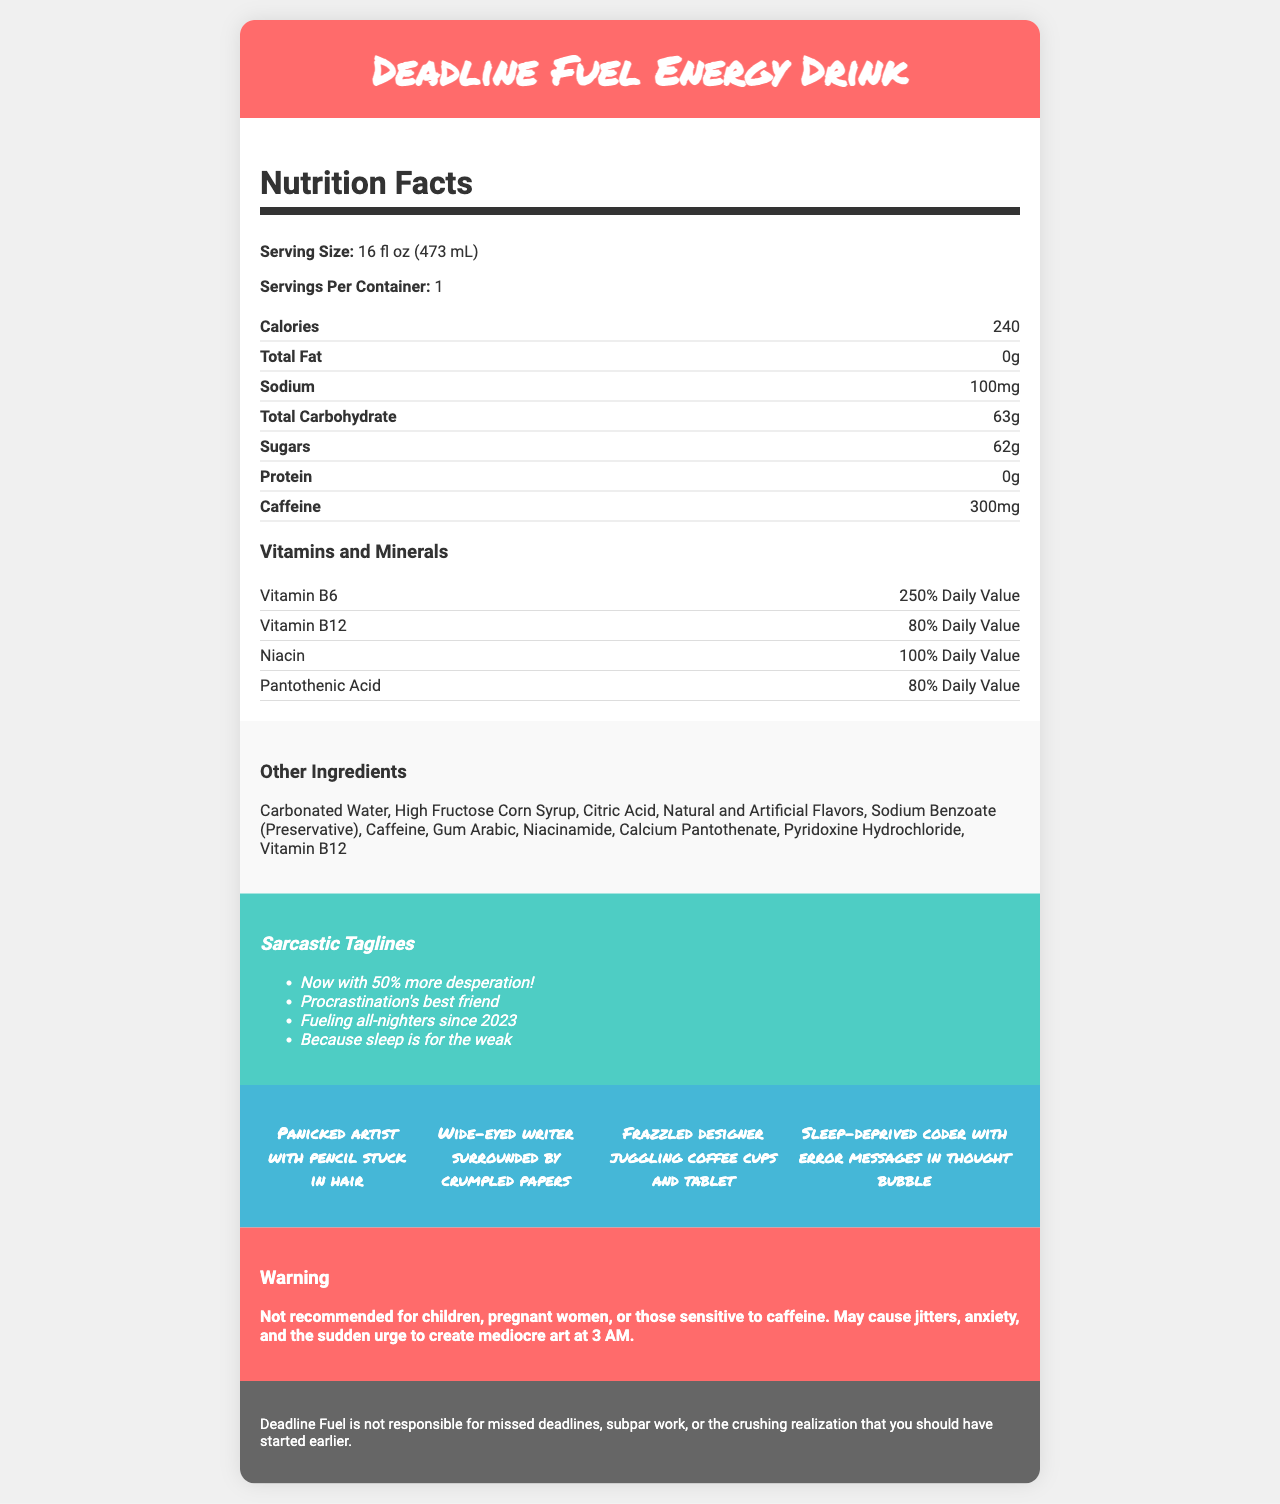what is the serving size of Deadline Fuel Energy Drink? The document states that the serving size of Deadline Fuel Energy Drink is 16 fl oz (473 mL).
Answer: 16 fl oz (473 mL) how many calories are in one serving of Deadline Fuel Energy Drink? The nutrition facts section lists the calories as 240 per serving.
Answer: 240 how much caffeine is in one serving of Deadline Fuel Energy Drink? The document specifies that each serving contains 300mg of caffeine.
Answer: 300mg which vitamin has the highest daily value percentage in Deadline Fuel Energy Drink? Vitamin B6 has a daily value percentage of 250%, which is higher than the other vitamins listed.
Answer: Vitamin B6 list three other ingredients found in Deadline Fuel Energy Drink The document lists multiple other ingredients, including Carbonated Water, High Fructose Corn Syrup, and Citric Acid.
Answer: Carbonated Water, High Fructose Corn Syrup, Citric Acid which sarcastic tagline could describe the relationship between the drink and procrastination?
A. Now with 50% more desperation
B. Procrastination's best friend
C. Fueling all-nighters since 2023
D. Because sleep is for the weak The tagline "Procrastination's best friend" directly relates the drink to procrastination.
Answer: B what is the sodium content in a serving of Deadline Fuel Energy Drink?
A. 50mg
B. 100mg
C. 200mg
D. 300mg The document indicates that the sodium content is 100mg per serving.
Answer: B is Deadline Fuel Energy Drink safe for children to consume? The warning explicitly states that the drink is not recommended for children, pregnant women, or those sensitive to caffeine.
Answer: No summarize the main theme of the document. The document outlines the detailed nutritional contents and ingredients of the drink while using sarcasm and humor to address its consumption context and target audience.
Answer: The document provides the nutrient profile of Deadline Fuel Energy Drink, emphasizing high caffeine and sugar content with added vitamins and minerals, accompanied by sarcastic taglines and humorous character sketches. how many protein grams are in one serving of Deadline Fuel Energy Drink? The nutrition facts list the protein content as 0g per serving.
Answer: 0g what might be a possible side effect of consuming Deadline Fuel Energy Drink according to the warning? The warning section mentions these specific side effects from consuming the drink.
Answer: Jitters, anxiety, and the sudden urge to create mediocre art at 3 AM which nutrient in Deadline Fuel Energy Drink is most closely associated with energy production and metabolism? Caffeine is well-known for its role in boosting energy and metabolism, which is aligned with the high 300mg caffeine content listed.
Answer: Caffeine what character sketch is used to depict a frazzled designer? One of the frantic character sketches describes a "Frazzled designer juggling coffee cups and tablet".
Answer: Frazzled designer juggling coffee cups and tablet how many sarcastic taglines are included in the document? The document lists four sarcastic taglines, including "Now with 50% more desperation!" and "Procrastination's best friend".
Answer: 4 are there any details about the taste or flavor of Deadline Fuel Energy Drink? The document does not provide any specific details about the taste or flavor of the drink. It only references "Natural and Artificial Flavors" in the ingredients.
Answer: Not enough information 